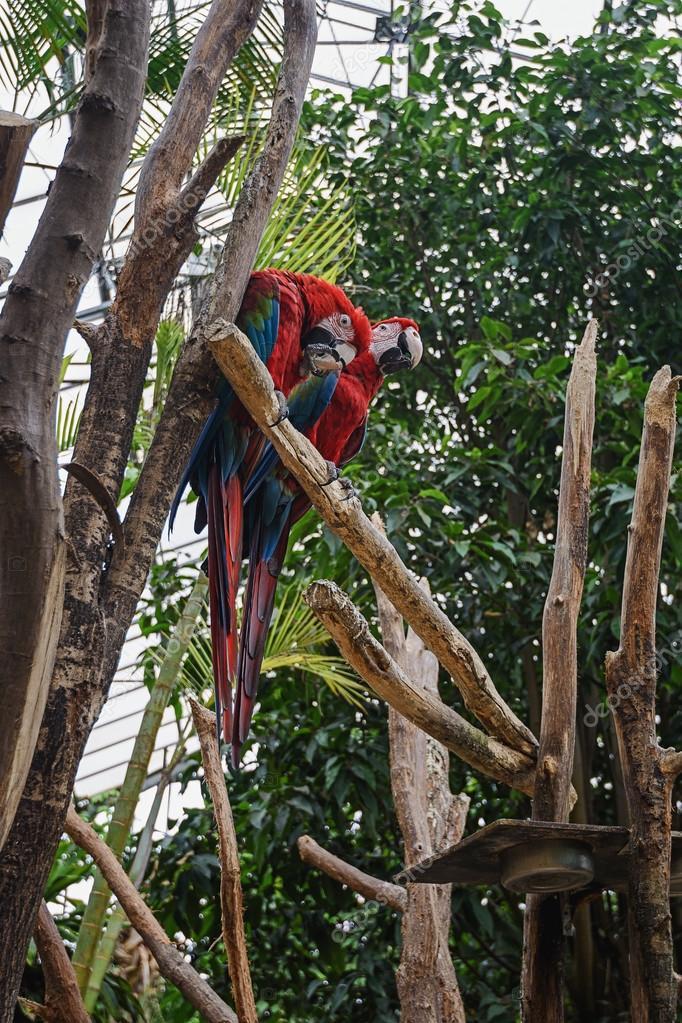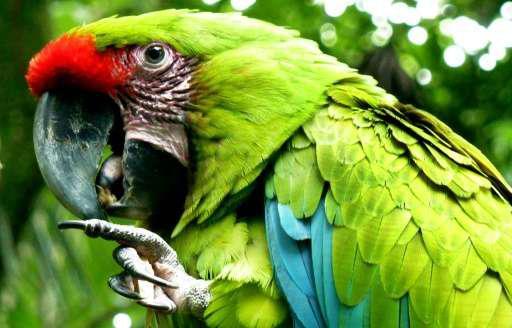The first image is the image on the left, the second image is the image on the right. Considering the images on both sides, is "The combined images contain no more than four parrots, and include a parrot with a green head and body." valid? Answer yes or no. Yes. The first image is the image on the left, the second image is the image on the right. Examine the images to the left and right. Is the description "The right image contains exactly two parrots." accurate? Answer yes or no. No. 